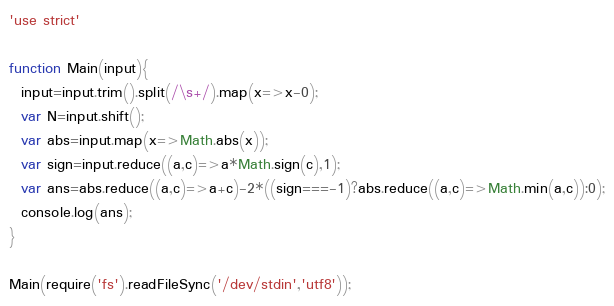<code> <loc_0><loc_0><loc_500><loc_500><_JavaScript_>'use strict'

function Main(input){
  input=input.trim().split(/\s+/).map(x=>x-0);
  var N=input.shift();
  var abs=input.map(x=>Math.abs(x));
  var sign=input.reduce((a,c)=>a*Math.sign(c),1);
  var ans=abs.reduce((a,c)=>a+c)-2*((sign===-1)?abs.reduce((a,c)=>Math.min(a,c)):0);
  console.log(ans);
}

Main(require('fs').readFileSync('/dev/stdin','utf8'));
</code> 